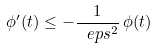<formula> <loc_0><loc_0><loc_500><loc_500>\phi ^ { \prime } ( t ) \leq - \frac { 1 } { \ e p s ^ { 2 } } \, \phi ( t )</formula> 